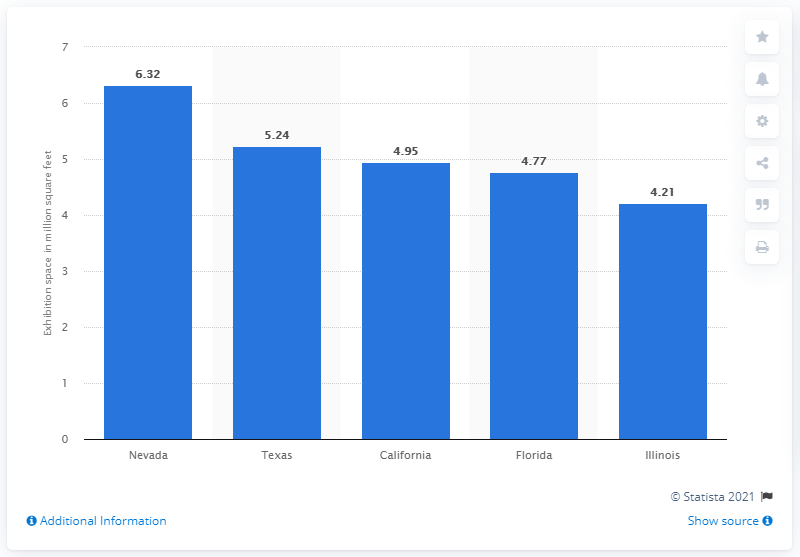Indicate a few pertinent items in this graphic. In Nevada, the total area covered by the state's convention centers was 6.32 square feet. 